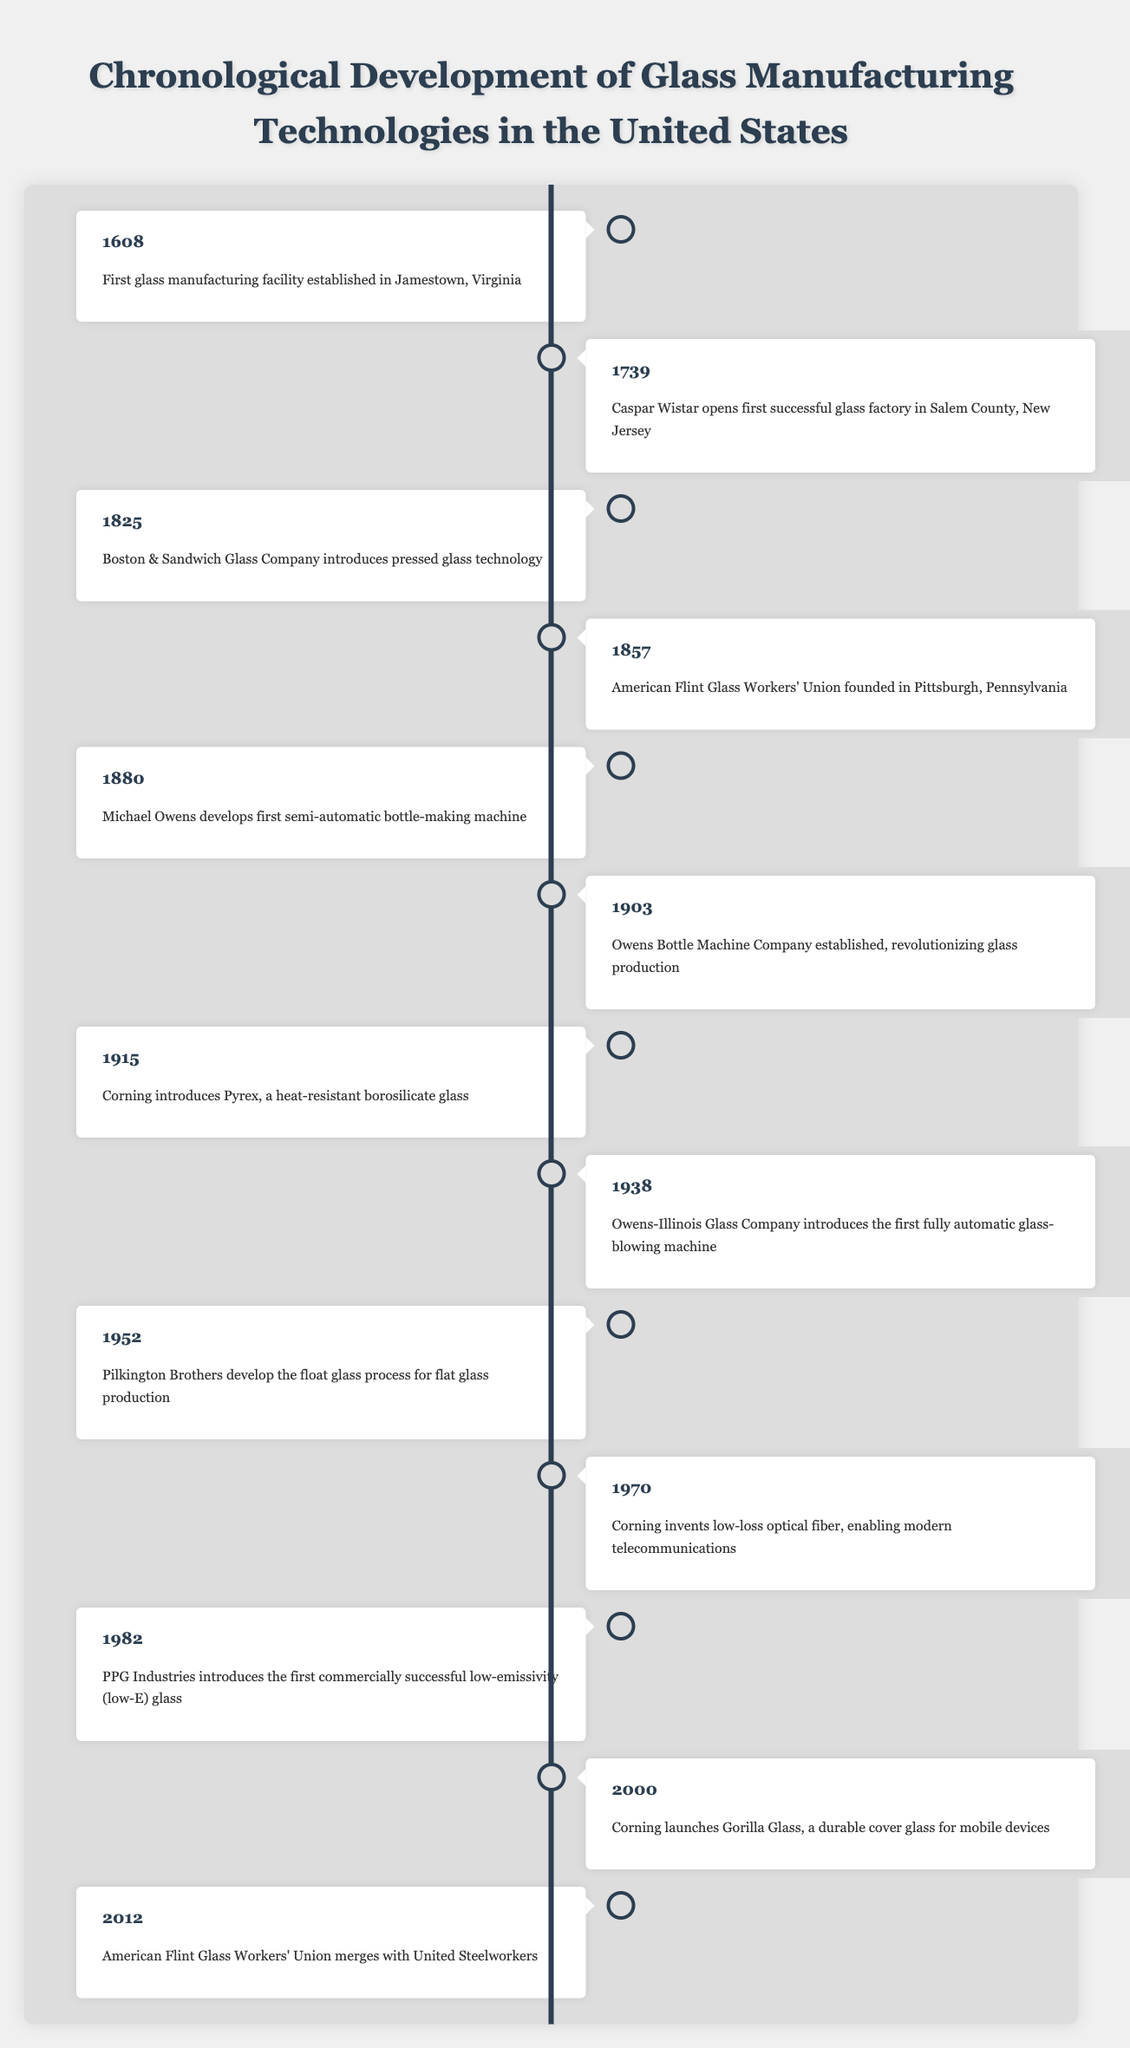What year was the first glass manufacturing facility established in the United States? According to the table, the event "First glass manufacturing facility established in Jamestown, Virginia" is listed with the year 1608.
Answer: 1608 Who founded the American Flint Glass Workers' Union, and when? The table shows that the American Flint Glass Workers' Union was founded in 1857 in Pittsburgh, Pennsylvania.
Answer: Founded in Pittsburgh, Pennsylvania, in 1857 Was the float glass process developed before or after the introduction of low-emissivity glass? The float glass process was developed in 1952 and low-emissivity glass was introduced in 1982, indicating that float glass was developed earlier.
Answer: Before What significant development occurred in 1903 regarding glass production? In 1903, the Owens Bottle Machine Company was established, which revolutionized glass production, according to the table.
Answer: Owens Bottle Machine Company established Which two events are closest in years according to the timeline? The events of 1938, when Owens-Illinois introduced the first fully automatic glass-blowing machine, and 1952 with the development of the float glass process are sequential. The difference in years is 14 years.
Answer: 1938 and 1952 How many years apart were the first semi-automatic bottle-making machine and the first fully automatic glass-blowing machine? The first semi-automatic bottle-making machine was developed in 1880, and the fully automatic glass-blowing machine was introduced in 1938. The difference is 1938 - 1880 = 58 years.
Answer: 58 years Was the introduction of Pyrex before or after the founding of the American Flint Glass Workers' Union? Pyrex was introduced in 1915, while the American Flint Glass Workers' Union was founded in 1857. This indicates Pyrex was introduced after the union's founding.
Answer: After What is the last event listed in the timeline? The last event, according to the table, is from 2012 when the American Flint Glass Workers' Union merged with the United Steelworkers.
Answer: 2012 merger with United Steelworkers In which year did Corning invent low-loss optical fiber? The table states that Corning invented low-loss optical fiber in the year 1970.
Answer: 1970 